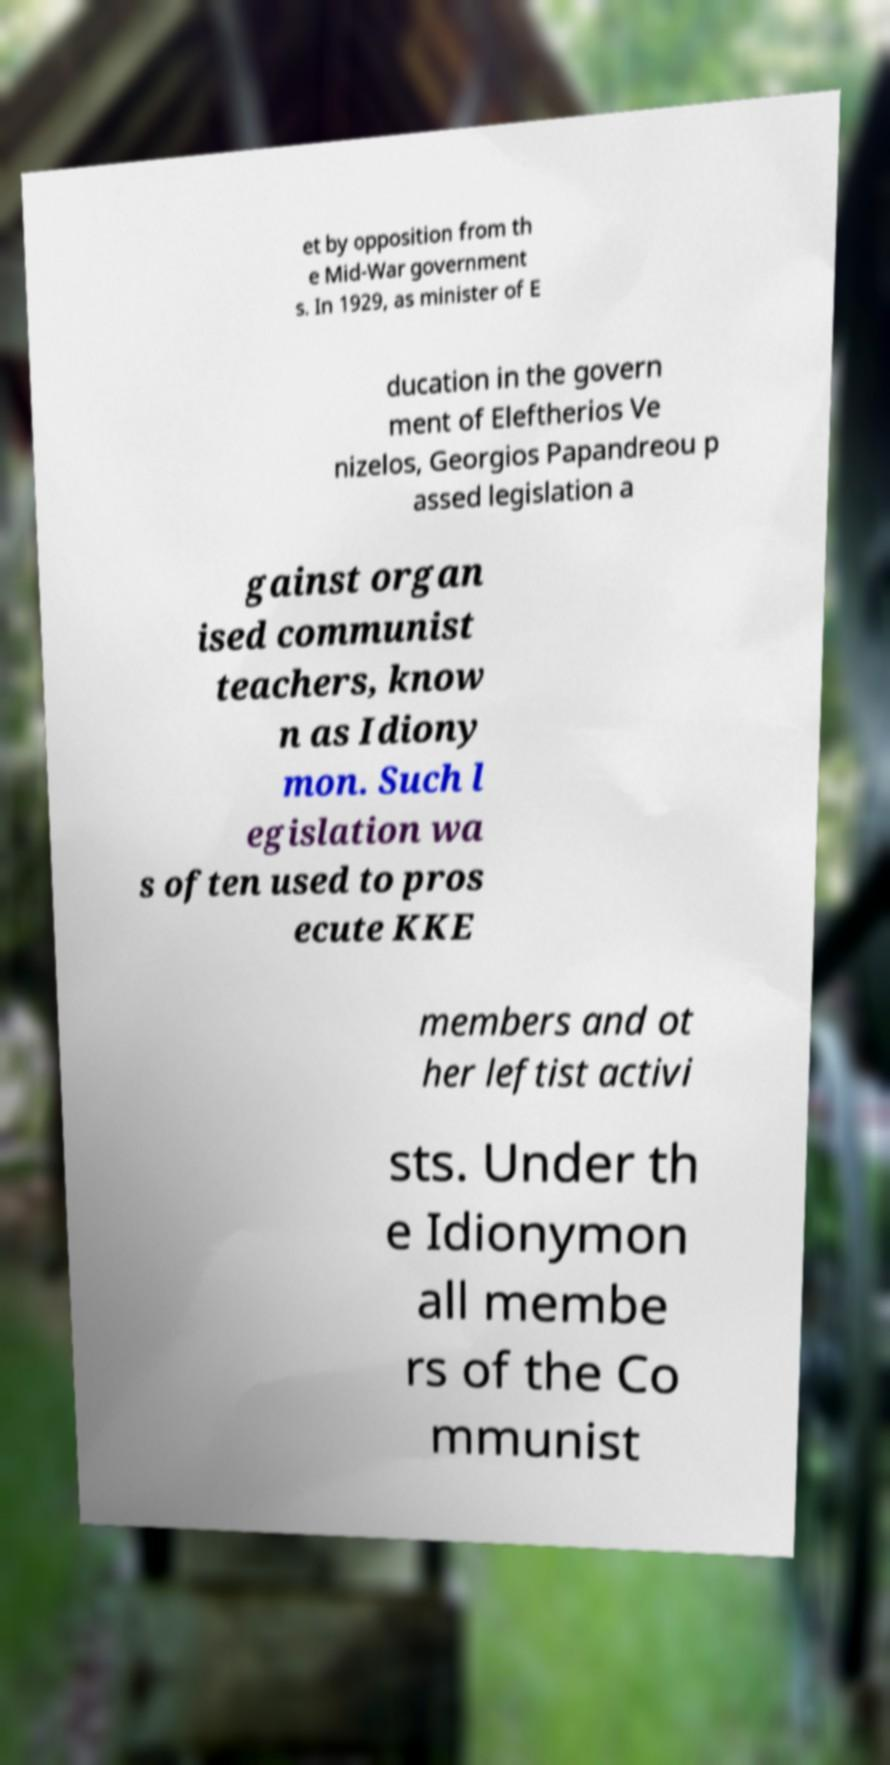Could you extract and type out the text from this image? et by opposition from th e Mid-War government s. In 1929, as minister of E ducation in the govern ment of Eleftherios Ve nizelos, Georgios Papandreou p assed legislation a gainst organ ised communist teachers, know n as Idiony mon. Such l egislation wa s often used to pros ecute KKE members and ot her leftist activi sts. Under th e Idionymon all membe rs of the Co mmunist 